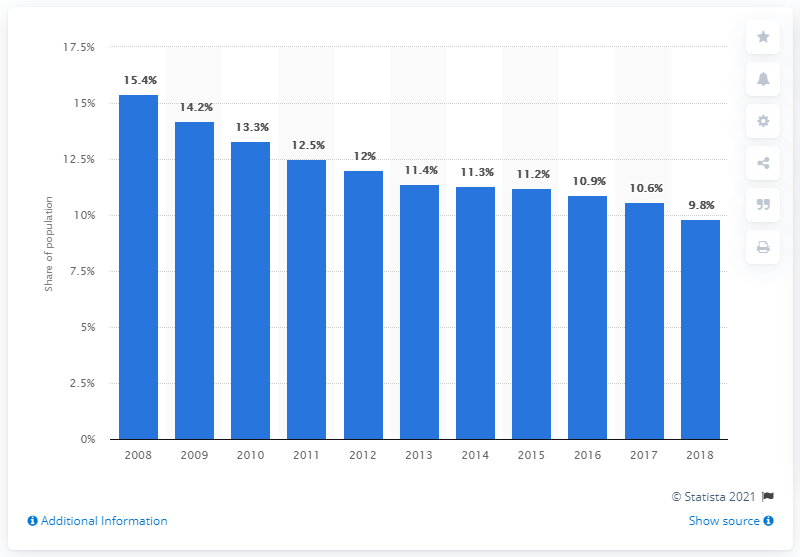Point out several critical features in this image. In 2018, the poverty headcount ratio at national poverty lines in Indonesia was 9.8. 